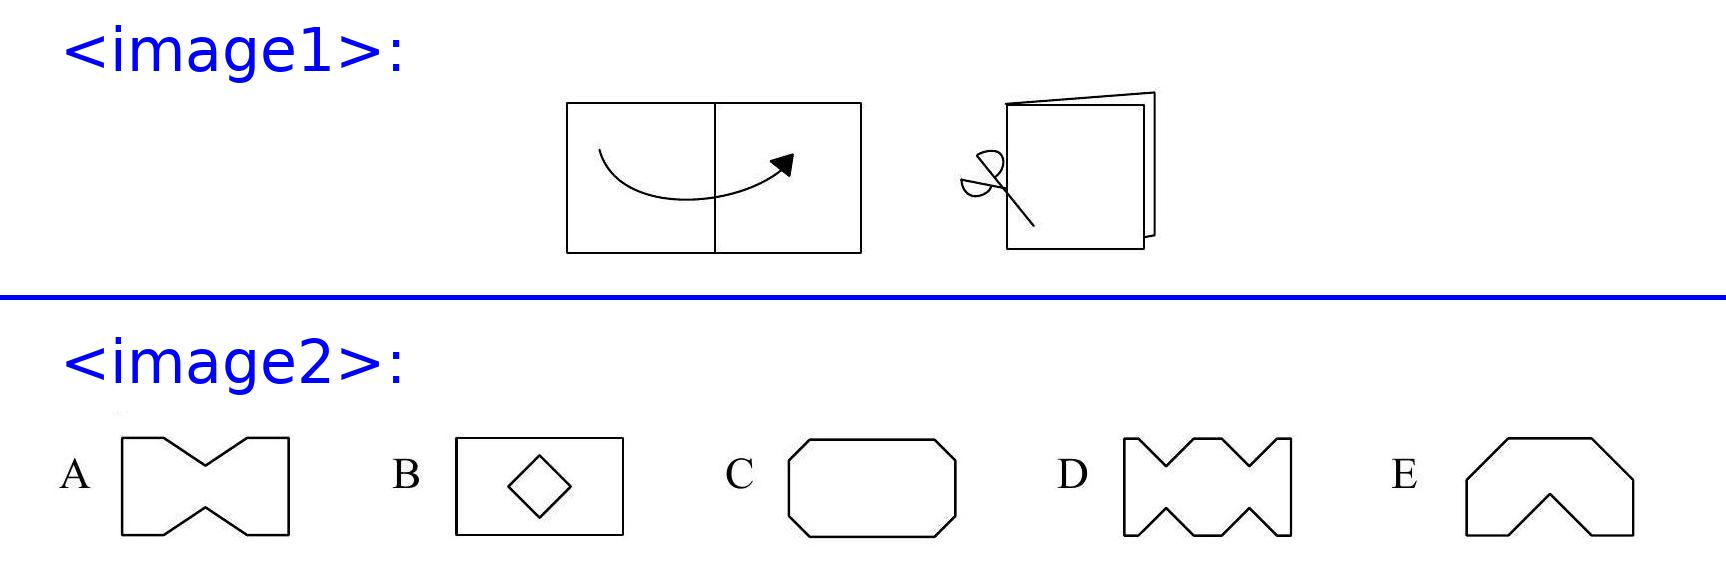Werner folds a sheet of paper as shown in the diagram and makes two straight cuts with a pair of scissors. He then opens up the paper again. Which of the following shapes cannot be the result? The correct answer is D. When Werner folds the paper as shown and makes the cuts, the cuts produce symmetric outcomes because the paper is folded in half. The options A, B, C, and E all represent such symmetric results, potentially achievable through various folding and cutting techniques, except for D, which has a non-symmetric shape which cannot be achieved by folding the paper in half and making two straight cuts. 